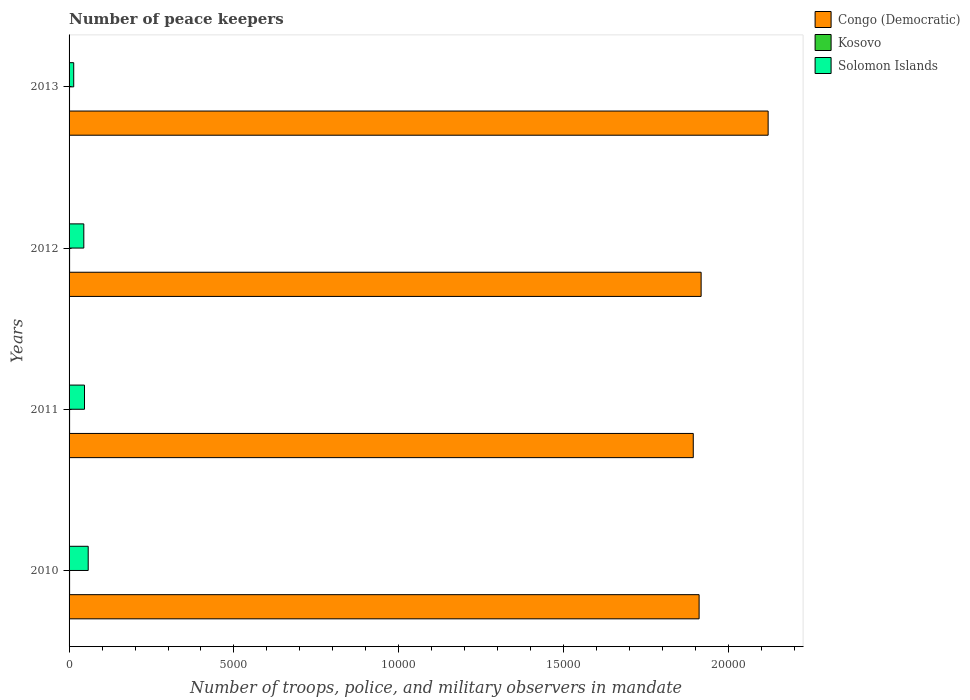How many different coloured bars are there?
Give a very brief answer. 3. Are the number of bars on each tick of the Y-axis equal?
Make the answer very short. Yes. What is the label of the 1st group of bars from the top?
Your response must be concise. 2013. What is the number of peace keepers in in Solomon Islands in 2012?
Keep it short and to the point. 447. Across all years, what is the maximum number of peace keepers in in Congo (Democratic)?
Your answer should be very brief. 2.12e+04. What is the difference between the number of peace keepers in in Solomon Islands in 2010 and the number of peace keepers in in Congo (Democratic) in 2013?
Offer a terse response. -2.06e+04. What is the average number of peace keepers in in Kosovo per year?
Offer a very short reply. 15.5. In the year 2012, what is the difference between the number of peace keepers in in Congo (Democratic) and number of peace keepers in in Solomon Islands?
Your response must be concise. 1.87e+04. What is the ratio of the number of peace keepers in in Solomon Islands in 2010 to that in 2013?
Your answer should be very brief. 4.11. What is the difference between the highest and the second highest number of peace keepers in in Solomon Islands?
Your answer should be very brief. 112. What is the difference between the highest and the lowest number of peace keepers in in Congo (Democratic)?
Give a very brief answer. 2270. Is the sum of the number of peace keepers in in Kosovo in 2012 and 2013 greater than the maximum number of peace keepers in in Solomon Islands across all years?
Provide a succinct answer. No. What does the 1st bar from the top in 2012 represents?
Keep it short and to the point. Solomon Islands. What does the 2nd bar from the bottom in 2012 represents?
Ensure brevity in your answer.  Kosovo. How many bars are there?
Your response must be concise. 12. Are the values on the major ticks of X-axis written in scientific E-notation?
Keep it short and to the point. No. Where does the legend appear in the graph?
Provide a succinct answer. Top right. How many legend labels are there?
Provide a short and direct response. 3. How are the legend labels stacked?
Your response must be concise. Vertical. What is the title of the graph?
Make the answer very short. Number of peace keepers. What is the label or title of the X-axis?
Provide a short and direct response. Number of troops, police, and military observers in mandate. What is the label or title of the Y-axis?
Provide a short and direct response. Years. What is the Number of troops, police, and military observers in mandate in Congo (Democratic) in 2010?
Make the answer very short. 1.91e+04. What is the Number of troops, police, and military observers in mandate in Kosovo in 2010?
Give a very brief answer. 16. What is the Number of troops, police, and military observers in mandate in Solomon Islands in 2010?
Keep it short and to the point. 580. What is the Number of troops, police, and military observers in mandate of Congo (Democratic) in 2011?
Your answer should be very brief. 1.89e+04. What is the Number of troops, police, and military observers in mandate in Kosovo in 2011?
Keep it short and to the point. 16. What is the Number of troops, police, and military observers in mandate of Solomon Islands in 2011?
Keep it short and to the point. 468. What is the Number of troops, police, and military observers in mandate of Congo (Democratic) in 2012?
Ensure brevity in your answer.  1.92e+04. What is the Number of troops, police, and military observers in mandate in Kosovo in 2012?
Give a very brief answer. 16. What is the Number of troops, police, and military observers in mandate in Solomon Islands in 2012?
Provide a succinct answer. 447. What is the Number of troops, police, and military observers in mandate of Congo (Democratic) in 2013?
Offer a terse response. 2.12e+04. What is the Number of troops, police, and military observers in mandate of Kosovo in 2013?
Make the answer very short. 14. What is the Number of troops, police, and military observers in mandate in Solomon Islands in 2013?
Give a very brief answer. 141. Across all years, what is the maximum Number of troops, police, and military observers in mandate in Congo (Democratic)?
Your answer should be compact. 2.12e+04. Across all years, what is the maximum Number of troops, police, and military observers in mandate of Kosovo?
Your response must be concise. 16. Across all years, what is the maximum Number of troops, police, and military observers in mandate of Solomon Islands?
Provide a succinct answer. 580. Across all years, what is the minimum Number of troops, police, and military observers in mandate in Congo (Democratic)?
Make the answer very short. 1.89e+04. Across all years, what is the minimum Number of troops, police, and military observers in mandate of Solomon Islands?
Your answer should be compact. 141. What is the total Number of troops, police, and military observers in mandate in Congo (Democratic) in the graph?
Provide a succinct answer. 7.84e+04. What is the total Number of troops, police, and military observers in mandate in Solomon Islands in the graph?
Give a very brief answer. 1636. What is the difference between the Number of troops, police, and military observers in mandate in Congo (Democratic) in 2010 and that in 2011?
Your answer should be compact. 177. What is the difference between the Number of troops, police, and military observers in mandate of Kosovo in 2010 and that in 2011?
Your answer should be compact. 0. What is the difference between the Number of troops, police, and military observers in mandate of Solomon Islands in 2010 and that in 2011?
Your answer should be very brief. 112. What is the difference between the Number of troops, police, and military observers in mandate of Congo (Democratic) in 2010 and that in 2012?
Your answer should be compact. -61. What is the difference between the Number of troops, police, and military observers in mandate of Kosovo in 2010 and that in 2012?
Your response must be concise. 0. What is the difference between the Number of troops, police, and military observers in mandate in Solomon Islands in 2010 and that in 2012?
Provide a short and direct response. 133. What is the difference between the Number of troops, police, and military observers in mandate in Congo (Democratic) in 2010 and that in 2013?
Offer a terse response. -2093. What is the difference between the Number of troops, police, and military observers in mandate in Kosovo in 2010 and that in 2013?
Your answer should be very brief. 2. What is the difference between the Number of troops, police, and military observers in mandate of Solomon Islands in 2010 and that in 2013?
Give a very brief answer. 439. What is the difference between the Number of troops, police, and military observers in mandate of Congo (Democratic) in 2011 and that in 2012?
Provide a succinct answer. -238. What is the difference between the Number of troops, police, and military observers in mandate of Congo (Democratic) in 2011 and that in 2013?
Your answer should be compact. -2270. What is the difference between the Number of troops, police, and military observers in mandate of Kosovo in 2011 and that in 2013?
Offer a very short reply. 2. What is the difference between the Number of troops, police, and military observers in mandate of Solomon Islands in 2011 and that in 2013?
Your answer should be compact. 327. What is the difference between the Number of troops, police, and military observers in mandate in Congo (Democratic) in 2012 and that in 2013?
Give a very brief answer. -2032. What is the difference between the Number of troops, police, and military observers in mandate in Solomon Islands in 2012 and that in 2013?
Your answer should be compact. 306. What is the difference between the Number of troops, police, and military observers in mandate of Congo (Democratic) in 2010 and the Number of troops, police, and military observers in mandate of Kosovo in 2011?
Your answer should be compact. 1.91e+04. What is the difference between the Number of troops, police, and military observers in mandate of Congo (Democratic) in 2010 and the Number of troops, police, and military observers in mandate of Solomon Islands in 2011?
Keep it short and to the point. 1.86e+04. What is the difference between the Number of troops, police, and military observers in mandate of Kosovo in 2010 and the Number of troops, police, and military observers in mandate of Solomon Islands in 2011?
Give a very brief answer. -452. What is the difference between the Number of troops, police, and military observers in mandate in Congo (Democratic) in 2010 and the Number of troops, police, and military observers in mandate in Kosovo in 2012?
Make the answer very short. 1.91e+04. What is the difference between the Number of troops, police, and military observers in mandate of Congo (Democratic) in 2010 and the Number of troops, police, and military observers in mandate of Solomon Islands in 2012?
Offer a terse response. 1.87e+04. What is the difference between the Number of troops, police, and military observers in mandate in Kosovo in 2010 and the Number of troops, police, and military observers in mandate in Solomon Islands in 2012?
Offer a very short reply. -431. What is the difference between the Number of troops, police, and military observers in mandate in Congo (Democratic) in 2010 and the Number of troops, police, and military observers in mandate in Kosovo in 2013?
Your answer should be compact. 1.91e+04. What is the difference between the Number of troops, police, and military observers in mandate in Congo (Democratic) in 2010 and the Number of troops, police, and military observers in mandate in Solomon Islands in 2013?
Your response must be concise. 1.90e+04. What is the difference between the Number of troops, police, and military observers in mandate of Kosovo in 2010 and the Number of troops, police, and military observers in mandate of Solomon Islands in 2013?
Your answer should be compact. -125. What is the difference between the Number of troops, police, and military observers in mandate in Congo (Democratic) in 2011 and the Number of troops, police, and military observers in mandate in Kosovo in 2012?
Your answer should be very brief. 1.89e+04. What is the difference between the Number of troops, police, and military observers in mandate of Congo (Democratic) in 2011 and the Number of troops, police, and military observers in mandate of Solomon Islands in 2012?
Provide a succinct answer. 1.85e+04. What is the difference between the Number of troops, police, and military observers in mandate in Kosovo in 2011 and the Number of troops, police, and military observers in mandate in Solomon Islands in 2012?
Your response must be concise. -431. What is the difference between the Number of troops, police, and military observers in mandate of Congo (Democratic) in 2011 and the Number of troops, police, and military observers in mandate of Kosovo in 2013?
Keep it short and to the point. 1.89e+04. What is the difference between the Number of troops, police, and military observers in mandate in Congo (Democratic) in 2011 and the Number of troops, police, and military observers in mandate in Solomon Islands in 2013?
Your answer should be compact. 1.88e+04. What is the difference between the Number of troops, police, and military observers in mandate in Kosovo in 2011 and the Number of troops, police, and military observers in mandate in Solomon Islands in 2013?
Your answer should be compact. -125. What is the difference between the Number of troops, police, and military observers in mandate in Congo (Democratic) in 2012 and the Number of troops, police, and military observers in mandate in Kosovo in 2013?
Your response must be concise. 1.92e+04. What is the difference between the Number of troops, police, and military observers in mandate of Congo (Democratic) in 2012 and the Number of troops, police, and military observers in mandate of Solomon Islands in 2013?
Your answer should be compact. 1.90e+04. What is the difference between the Number of troops, police, and military observers in mandate of Kosovo in 2012 and the Number of troops, police, and military observers in mandate of Solomon Islands in 2013?
Provide a succinct answer. -125. What is the average Number of troops, police, and military observers in mandate of Congo (Democratic) per year?
Ensure brevity in your answer.  1.96e+04. What is the average Number of troops, police, and military observers in mandate of Kosovo per year?
Your answer should be very brief. 15.5. What is the average Number of troops, police, and military observers in mandate in Solomon Islands per year?
Offer a very short reply. 409. In the year 2010, what is the difference between the Number of troops, police, and military observers in mandate in Congo (Democratic) and Number of troops, police, and military observers in mandate in Kosovo?
Give a very brief answer. 1.91e+04. In the year 2010, what is the difference between the Number of troops, police, and military observers in mandate of Congo (Democratic) and Number of troops, police, and military observers in mandate of Solomon Islands?
Provide a short and direct response. 1.85e+04. In the year 2010, what is the difference between the Number of troops, police, and military observers in mandate of Kosovo and Number of troops, police, and military observers in mandate of Solomon Islands?
Offer a terse response. -564. In the year 2011, what is the difference between the Number of troops, police, and military observers in mandate in Congo (Democratic) and Number of troops, police, and military observers in mandate in Kosovo?
Ensure brevity in your answer.  1.89e+04. In the year 2011, what is the difference between the Number of troops, police, and military observers in mandate of Congo (Democratic) and Number of troops, police, and military observers in mandate of Solomon Islands?
Your answer should be compact. 1.85e+04. In the year 2011, what is the difference between the Number of troops, police, and military observers in mandate in Kosovo and Number of troops, police, and military observers in mandate in Solomon Islands?
Your answer should be compact. -452. In the year 2012, what is the difference between the Number of troops, police, and military observers in mandate of Congo (Democratic) and Number of troops, police, and military observers in mandate of Kosovo?
Your answer should be very brief. 1.92e+04. In the year 2012, what is the difference between the Number of troops, police, and military observers in mandate of Congo (Democratic) and Number of troops, police, and military observers in mandate of Solomon Islands?
Provide a succinct answer. 1.87e+04. In the year 2012, what is the difference between the Number of troops, police, and military observers in mandate of Kosovo and Number of troops, police, and military observers in mandate of Solomon Islands?
Keep it short and to the point. -431. In the year 2013, what is the difference between the Number of troops, police, and military observers in mandate in Congo (Democratic) and Number of troops, police, and military observers in mandate in Kosovo?
Your response must be concise. 2.12e+04. In the year 2013, what is the difference between the Number of troops, police, and military observers in mandate of Congo (Democratic) and Number of troops, police, and military observers in mandate of Solomon Islands?
Provide a short and direct response. 2.11e+04. In the year 2013, what is the difference between the Number of troops, police, and military observers in mandate of Kosovo and Number of troops, police, and military observers in mandate of Solomon Islands?
Give a very brief answer. -127. What is the ratio of the Number of troops, police, and military observers in mandate of Congo (Democratic) in 2010 to that in 2011?
Keep it short and to the point. 1.01. What is the ratio of the Number of troops, police, and military observers in mandate of Solomon Islands in 2010 to that in 2011?
Ensure brevity in your answer.  1.24. What is the ratio of the Number of troops, police, and military observers in mandate in Kosovo in 2010 to that in 2012?
Keep it short and to the point. 1. What is the ratio of the Number of troops, police, and military observers in mandate of Solomon Islands in 2010 to that in 2012?
Keep it short and to the point. 1.3. What is the ratio of the Number of troops, police, and military observers in mandate of Congo (Democratic) in 2010 to that in 2013?
Your answer should be compact. 0.9. What is the ratio of the Number of troops, police, and military observers in mandate in Solomon Islands in 2010 to that in 2013?
Provide a short and direct response. 4.11. What is the ratio of the Number of troops, police, and military observers in mandate in Congo (Democratic) in 2011 to that in 2012?
Keep it short and to the point. 0.99. What is the ratio of the Number of troops, police, and military observers in mandate in Solomon Islands in 2011 to that in 2012?
Your response must be concise. 1.05. What is the ratio of the Number of troops, police, and military observers in mandate in Congo (Democratic) in 2011 to that in 2013?
Your answer should be very brief. 0.89. What is the ratio of the Number of troops, police, and military observers in mandate of Solomon Islands in 2011 to that in 2013?
Provide a succinct answer. 3.32. What is the ratio of the Number of troops, police, and military observers in mandate of Congo (Democratic) in 2012 to that in 2013?
Your answer should be compact. 0.9. What is the ratio of the Number of troops, police, and military observers in mandate in Solomon Islands in 2012 to that in 2013?
Make the answer very short. 3.17. What is the difference between the highest and the second highest Number of troops, police, and military observers in mandate in Congo (Democratic)?
Your answer should be compact. 2032. What is the difference between the highest and the second highest Number of troops, police, and military observers in mandate of Solomon Islands?
Provide a short and direct response. 112. What is the difference between the highest and the lowest Number of troops, police, and military observers in mandate of Congo (Democratic)?
Ensure brevity in your answer.  2270. What is the difference between the highest and the lowest Number of troops, police, and military observers in mandate in Kosovo?
Give a very brief answer. 2. What is the difference between the highest and the lowest Number of troops, police, and military observers in mandate in Solomon Islands?
Offer a very short reply. 439. 